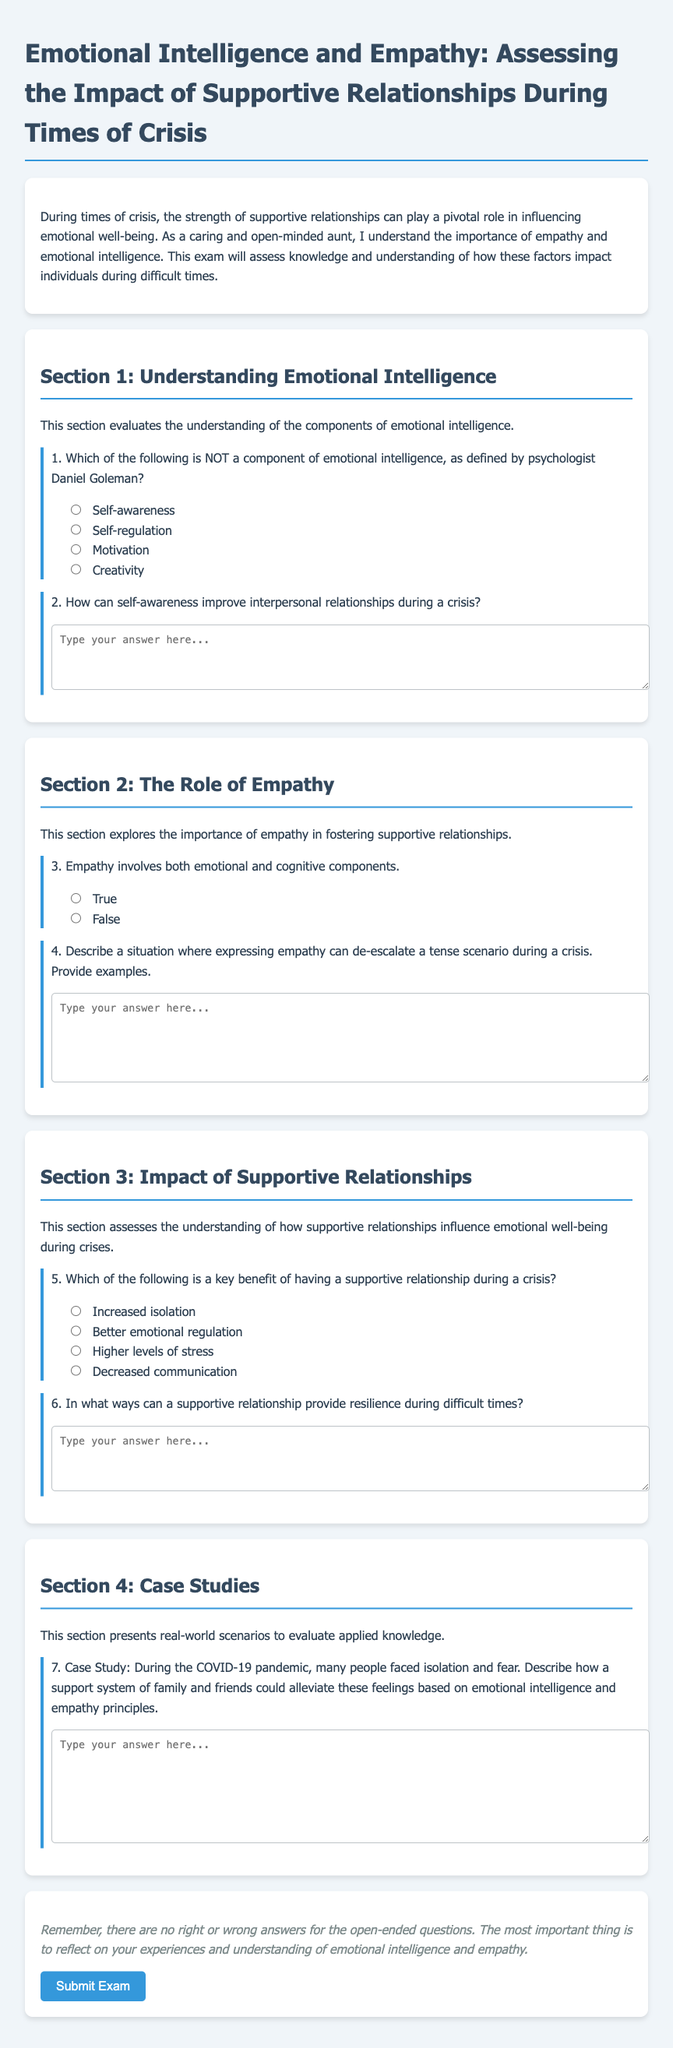What is the title of the exam? The title of the exam is displayed at the top of the document and serves as the main subject matter of the content.
Answer: Emotional Intelligence and Empathy: Assessing the Impact of Supportive Relationships During Times of Crisis Who is the intended audience for the exam? The intended audience is hinted at in the introduction describing the context in which the content is relevant and who would benefit from it.
Answer: Caring and open-minded aunt What is the first component of emotional intelligence listed? The document presents a list of components of emotional intelligence, and the first option is indicated in the multiple-choice question.
Answer: Self-awareness How many sections are there in the exam? The document is structured into clearly defined sections, which can be counted from the headings presented in the content.
Answer: Four What is the purpose of Section 2? This section's purpose is explained in the text preceding the questions, indicating what knowledge it aims to assess.
Answer: Explore the importance of empathy in fostering supportive relationships Is the statement about empathy true or false? The question in the document requires a response based on understanding of the components of empathy as described.
Answer: True What kind of situations does the case study address? The case study focuses on specific scenarios that illustrate real-world applications of concepts discussed in the exam, which can be identified in the description.
Answer: Isolation and fear during the COVID-19 pandemic What is the benefit of a supportive relationship during a crisis? The document includes options for a key benefit, which addresses the effect of supportive relationships in stressful situations.
Answer: Better emotional regulation 